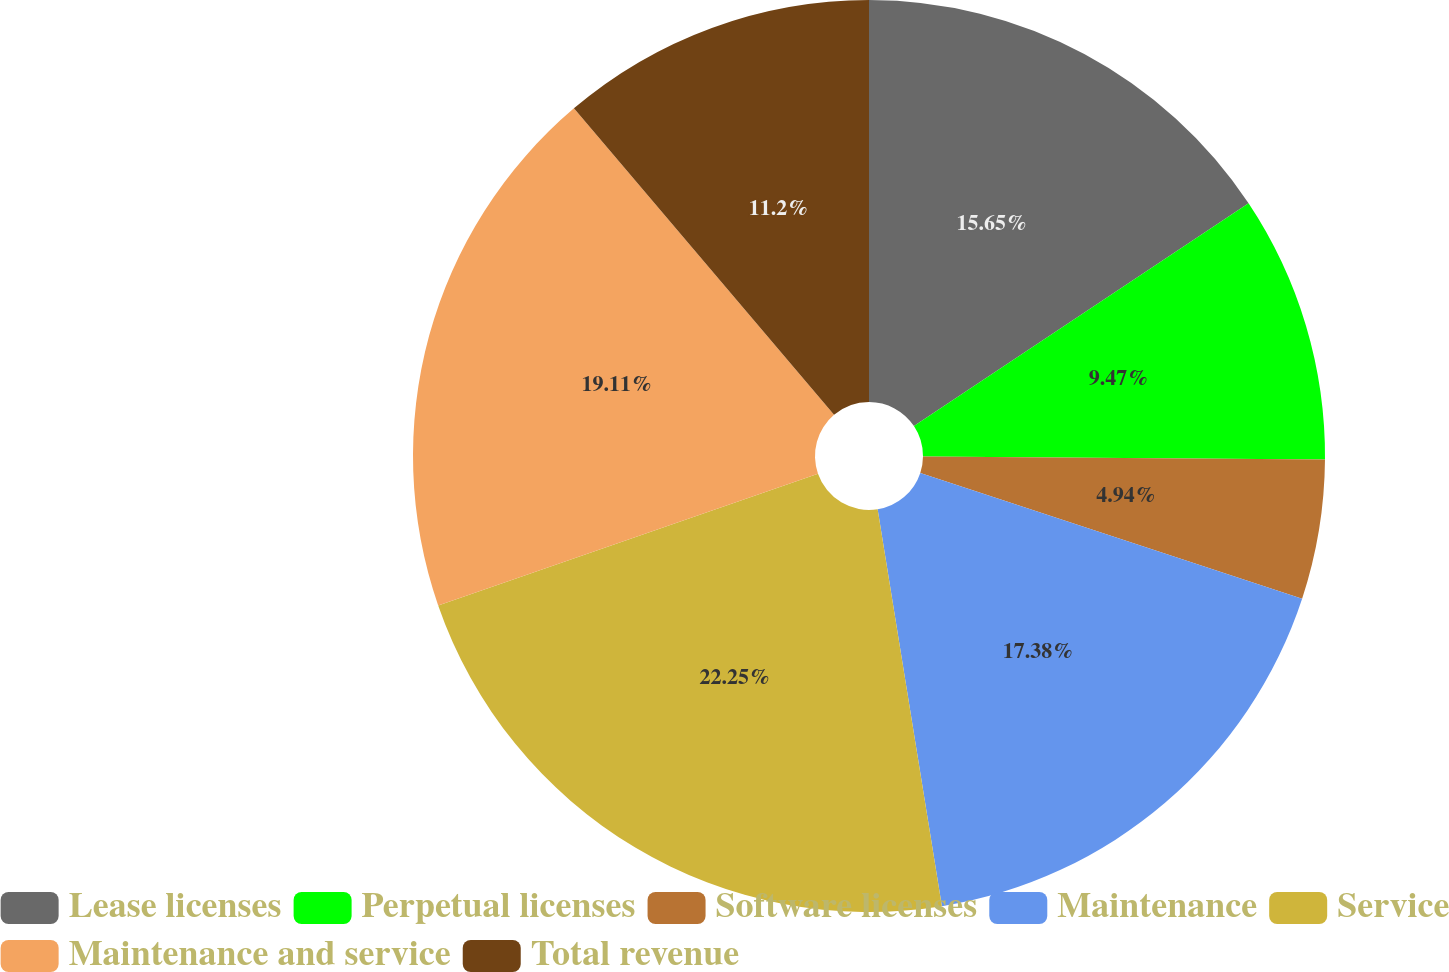<chart> <loc_0><loc_0><loc_500><loc_500><pie_chart><fcel>Lease licenses<fcel>Perpetual licenses<fcel>Software licenses<fcel>Maintenance<fcel>Service<fcel>Maintenance and service<fcel>Total revenue<nl><fcel>15.65%<fcel>9.47%<fcel>4.94%<fcel>17.38%<fcel>22.24%<fcel>19.11%<fcel>11.2%<nl></chart> 